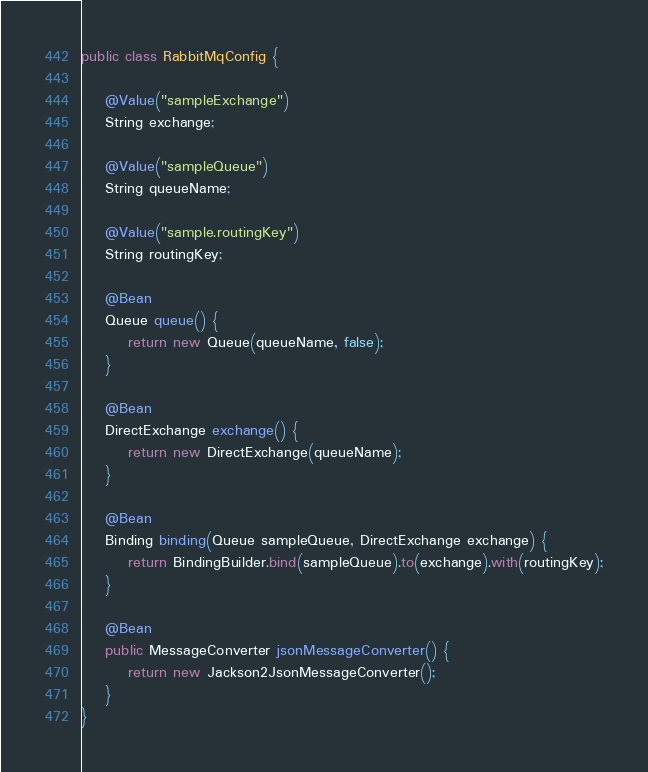Convert code to text. <code><loc_0><loc_0><loc_500><loc_500><_Java_>public class RabbitMqConfig {

    @Value("sampleExchange")
    String exchange;

    @Value("sampleQueue")
    String queueName;

    @Value("sample.routingKey")
    String routingKey;

    @Bean
    Queue queue() {
        return new Queue(queueName, false);
    }

    @Bean
    DirectExchange exchange() {
        return new DirectExchange(queueName);
    }

    @Bean
    Binding binding(Queue sampleQueue, DirectExchange exchange) {
        return BindingBuilder.bind(sampleQueue).to(exchange).with(routingKey);
    }

    @Bean
    public MessageConverter jsonMessageConverter() {
        return new Jackson2JsonMessageConverter();
    }
}
</code> 